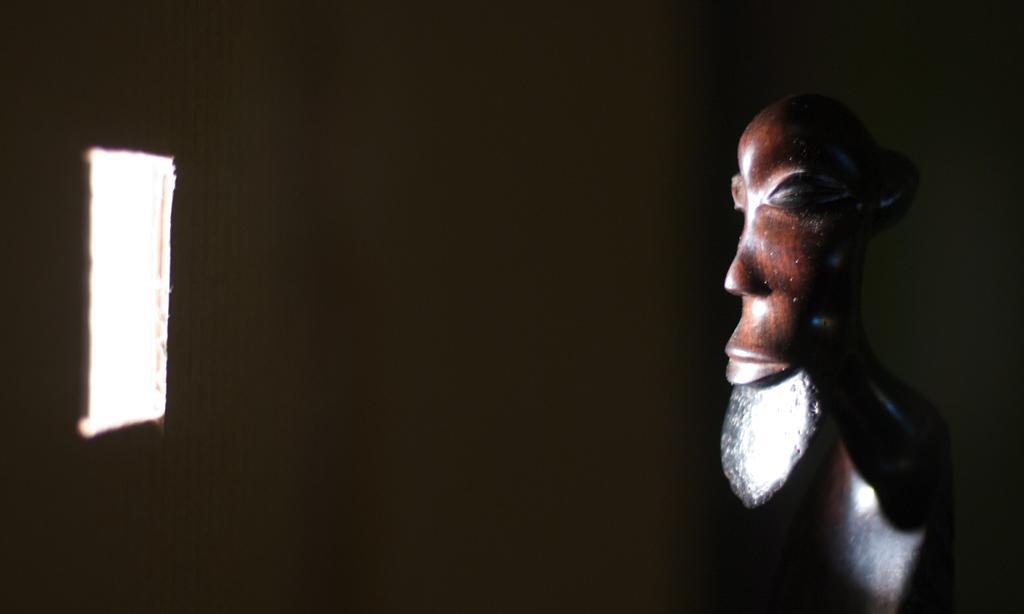Could you give a brief overview of what you see in this image? This picture describe about the small wooden sculpture in the image. Beside we can see a small window from which sunlight is falling on the wooden sculpture. 